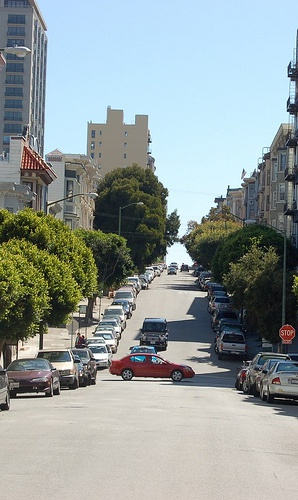Describe the objects in this image and their specific colors. I can see car in gray, darkgray, lightgray, and black tones, car in gray, black, and darkgray tones, car in gray, maroon, black, and darkgray tones, car in gray, darkgray, black, and blue tones, and car in gray, black, ivory, and darkgray tones in this image. 